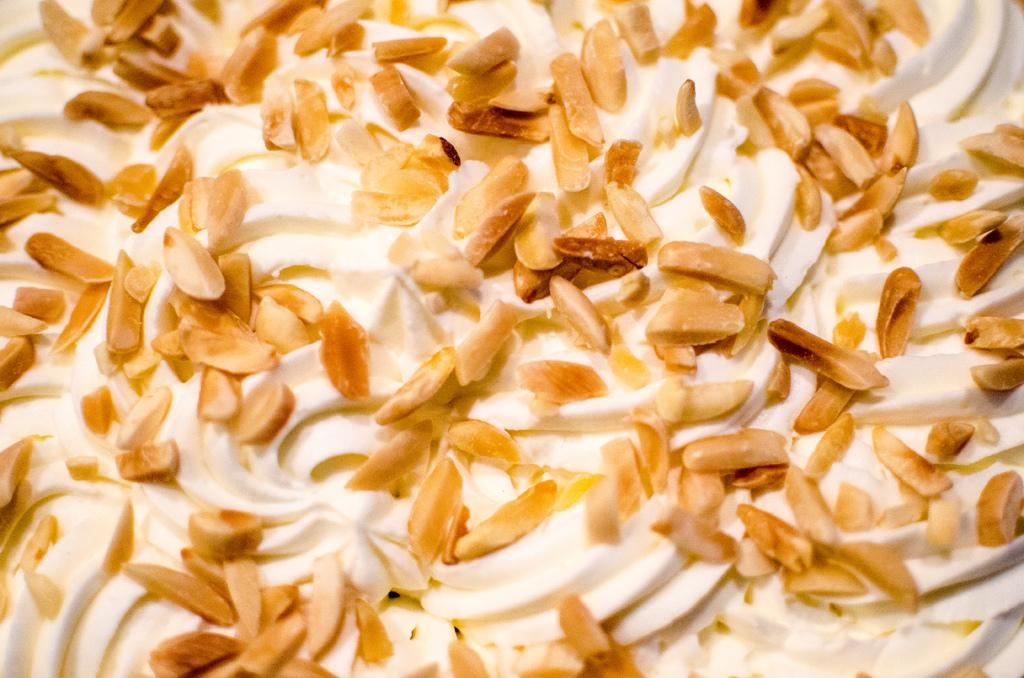What type of food is present in the image? There are dry fruits in the image. How are the dry fruits prepared or served? The dry fruits are in cream. What color of paint is being used on the truck in the image? There is no truck present in the image, so we cannot determine the color of paint being used. 